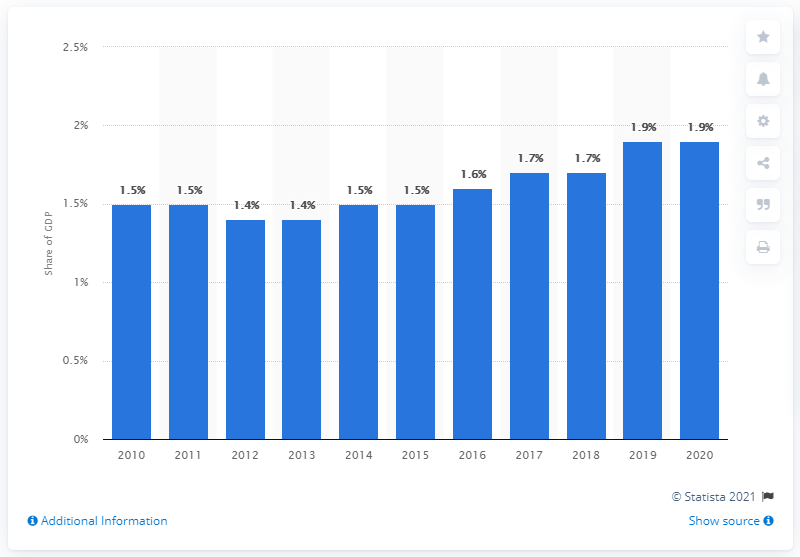Give some essential details in this illustration. According to data from 2020, military expenditures in Norway accounted for approximately 1.9% of the country's Gross Domestic Product (GDP). The GDP of Norway in 2019 was 1.9 trillion. 